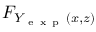Convert formula to latex. <formula><loc_0><loc_0><loc_500><loc_500>F _ { Y _ { e x p } ( x , z ) }</formula> 